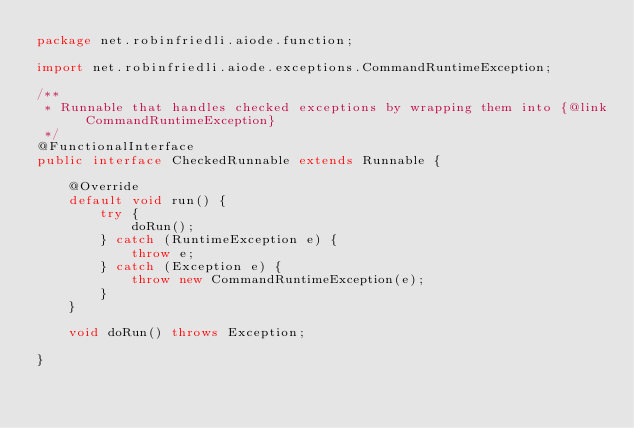<code> <loc_0><loc_0><loc_500><loc_500><_Java_>package net.robinfriedli.aiode.function;

import net.robinfriedli.aiode.exceptions.CommandRuntimeException;

/**
 * Runnable that handles checked exceptions by wrapping them into {@link CommandRuntimeException}
 */
@FunctionalInterface
public interface CheckedRunnable extends Runnable {

    @Override
    default void run() {
        try {
            doRun();
        } catch (RuntimeException e) {
            throw e;
        } catch (Exception e) {
            throw new CommandRuntimeException(e);
        }
    }

    void doRun() throws Exception;

}
</code> 